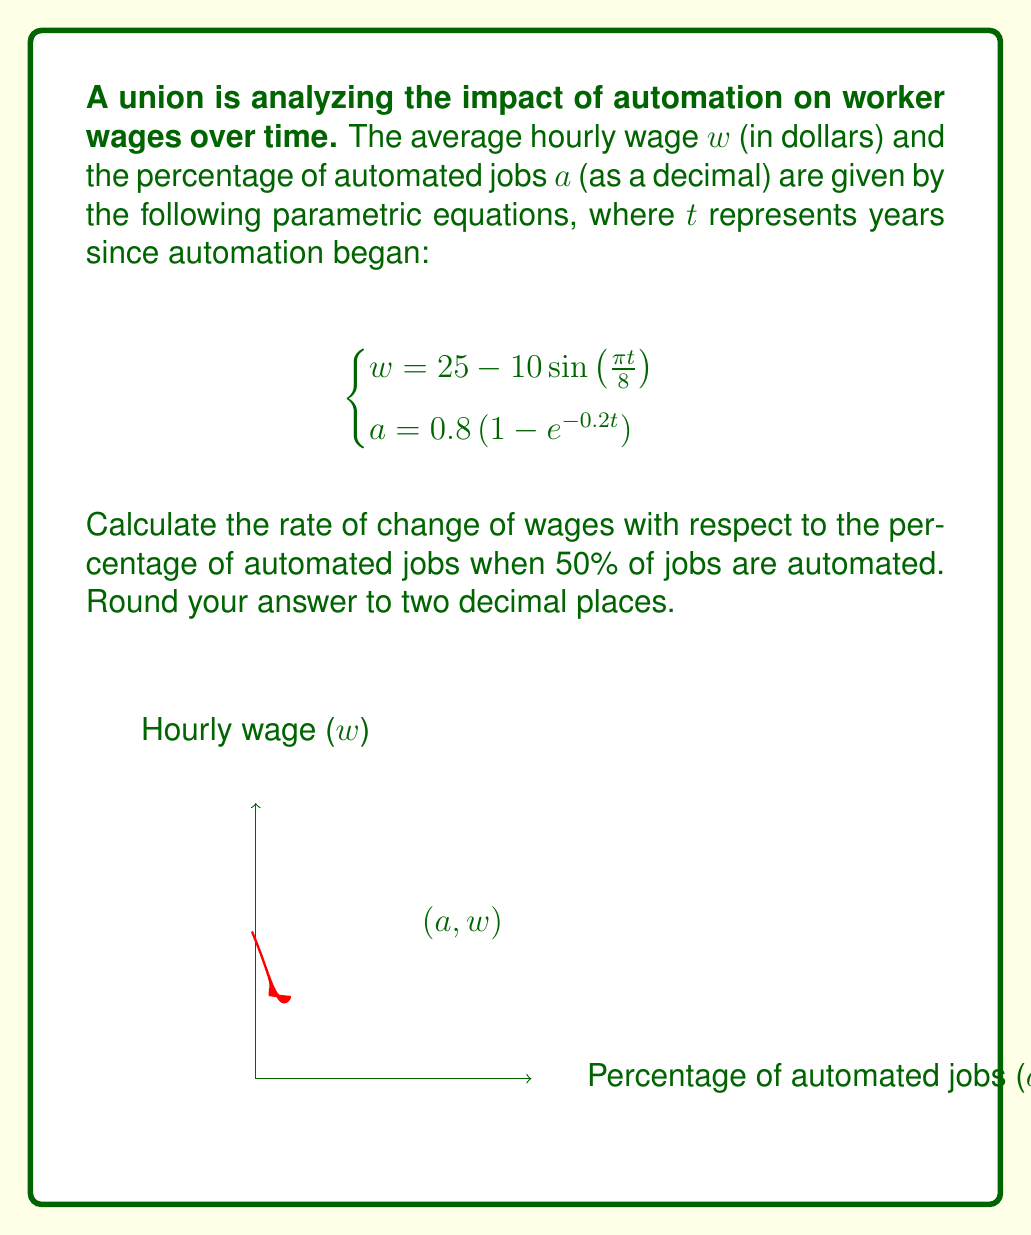Could you help me with this problem? To solve this problem, we'll follow these steps:

1) First, we need to find $t$ when $a = 0.5$:
   
   $0.5 = 0.8(1 - e^{-0.2t})$
   $0.625 = 1 - e^{-0.2t}$
   $e^{-0.2t} = 0.375$
   $-0.2t = \ln(0.375)$
   $t = -\frac{\ln(0.375)}{0.2} \approx 4.9386$ years

2) Now we need to calculate $\frac{dw}{da}$ at this point. We can use the chain rule:

   $\frac{dw}{da} = \frac{dw/dt}{da/dt}$

3) Let's calculate $\frac{dw}{dt}$:
   
   $\frac{dw}{dt} = -10 \cdot \frac{\pi}{8} \cos(\frac{\pi t}{8}) = -\frac{5\pi}{4} \cos(\frac{\pi t}{8})$

4) Now let's calculate $\frac{da}{dt}$:
   
   $\frac{da}{dt} = 0.8 \cdot 0.2e^{-0.2t} = 0.16e^{-0.2t}$

5) Substituting $t = 4.9386$ into these expressions:

   $\frac{dw}{dt} = -\frac{5\pi}{4} \cos(\frac{\pi \cdot 4.9386}{8}) \approx -3.4674$
   
   $\frac{da}{dt} = 0.16e^{-0.2 \cdot 4.9386} \approx 0.0800$

6) Now we can calculate $\frac{dw}{da}$:

   $\frac{dw}{da} = \frac{-3.4674}{0.0800} \approx -43.34$

7) Rounding to two decimal places gives -43.34.
Answer: $-43.34$ dollars per 1% increase in automation 